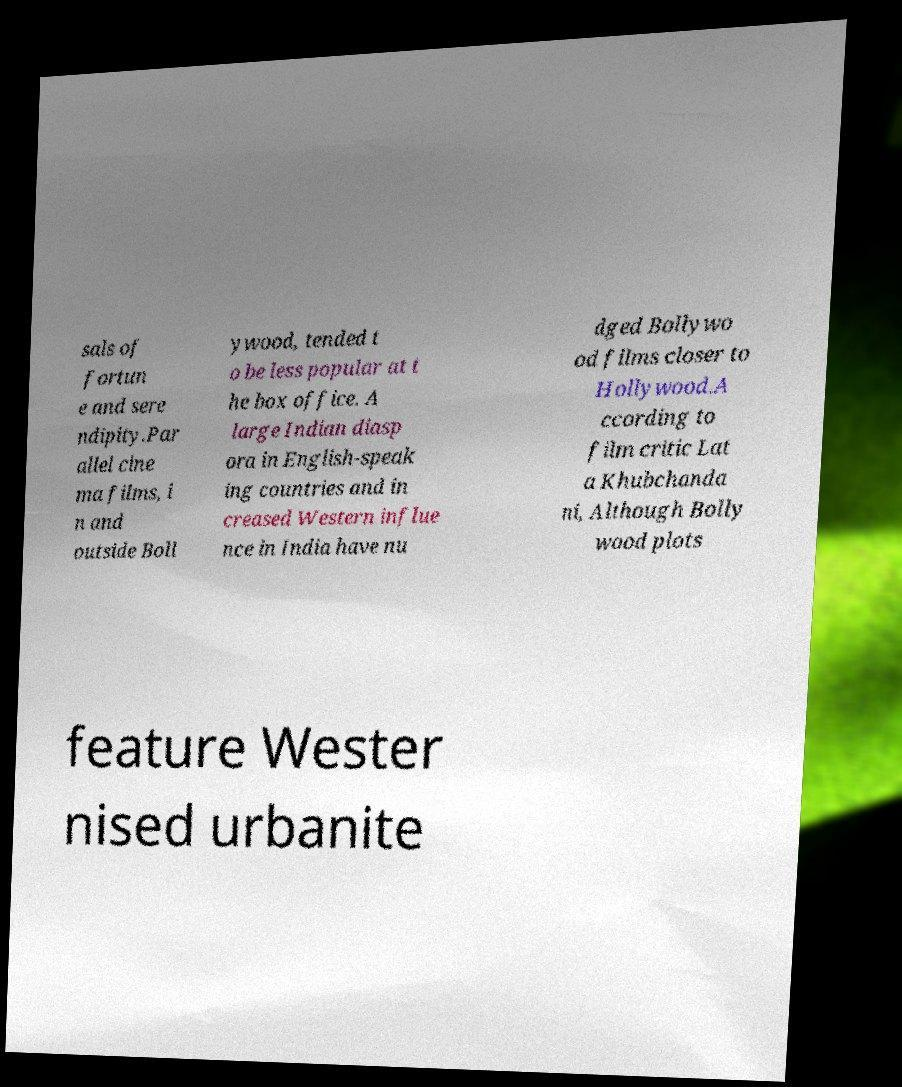Can you read and provide the text displayed in the image?This photo seems to have some interesting text. Can you extract and type it out for me? sals of fortun e and sere ndipity.Par allel cine ma films, i n and outside Boll ywood, tended t o be less popular at t he box office. A large Indian diasp ora in English-speak ing countries and in creased Western influe nce in India have nu dged Bollywo od films closer to Hollywood.A ccording to film critic Lat a Khubchanda ni, Although Bolly wood plots feature Wester nised urbanite 